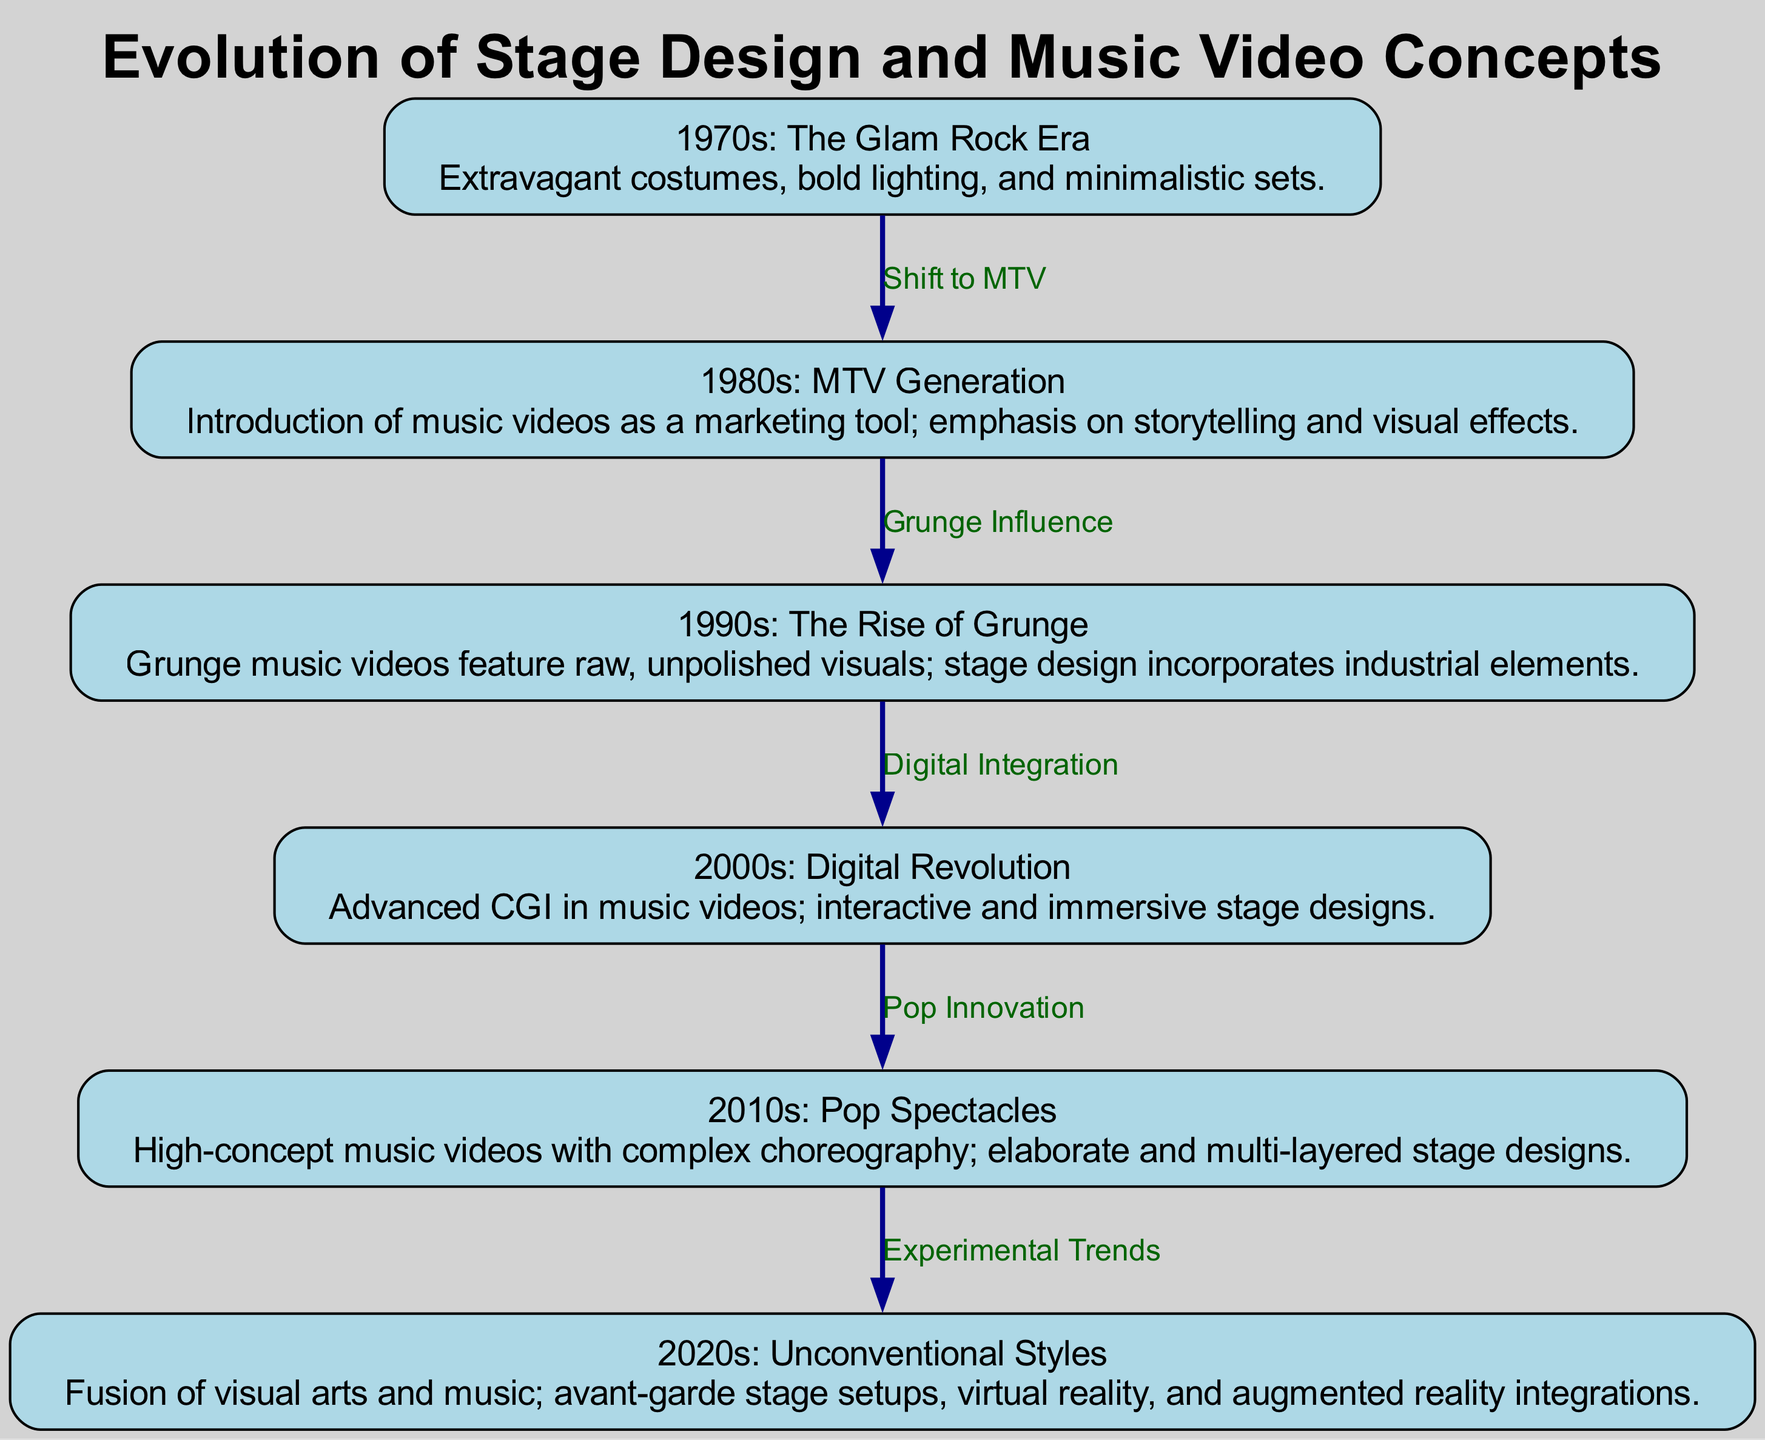What is the first era shown in the diagram? The diagram begins with the 1970s, specifically highlighting "The Glam Rock Era." This is the first node listed among all the eras represented in the diagram.
Answer: The Glam Rock Era How many total eras are represented in the diagram? By counting all the nodes listed in the diagram, there are six distinct eras included, from the 1970s to the 2020s.
Answer: 6 What is the main characteristic of the 1980s music video generation? The 1980s era is characterized by the introduction of music videos as a marketing tool and an emphasis on storytelling and visual effects. This detail outlines the key aspect of the era.
Answer: Introduction of music videos as a marketing tool Which era follows the 1990s with a digital integration influence? The era that follows the 1990s is the 2000s, which is marked by advanced CGI in music videos and other digital advancements in stage design. This is indicated by the edge connecting nodes 3 and 4.
Answer: 2000s What relationship does the 1980s have with the 1990s? The relationship is described by the label "Grunge Influence," which indicates that the 1990s were influenced by the trends established in the 1980s, specifically in music and visuals.
Answer: Grunge Influence What type of stage design is described for the 2020s? The 2020s are noted for avant-garde stage setups that incorporate virtual reality and augmented reality. This unique combination highlights the unconventional styles prevalent in this era.
Answer: Avant-garde stage setups What progression is indicated from the 2000s to the 2010s? The transition from the 2000s to the 2010s is marked by the label "Pop Innovation," suggesting that the innovations in pop music styles and visuals progressed heavily into the next decade.
Answer: Pop Innovation How does the diagram depict the connection between the 2010s and the 2020s? The connection between the 2010s and the 2020s is reflected by the "Experimental Trends," showing a continuous evolution towards more unique and alternative stage designs and music video concepts.
Answer: Experimental Trends 